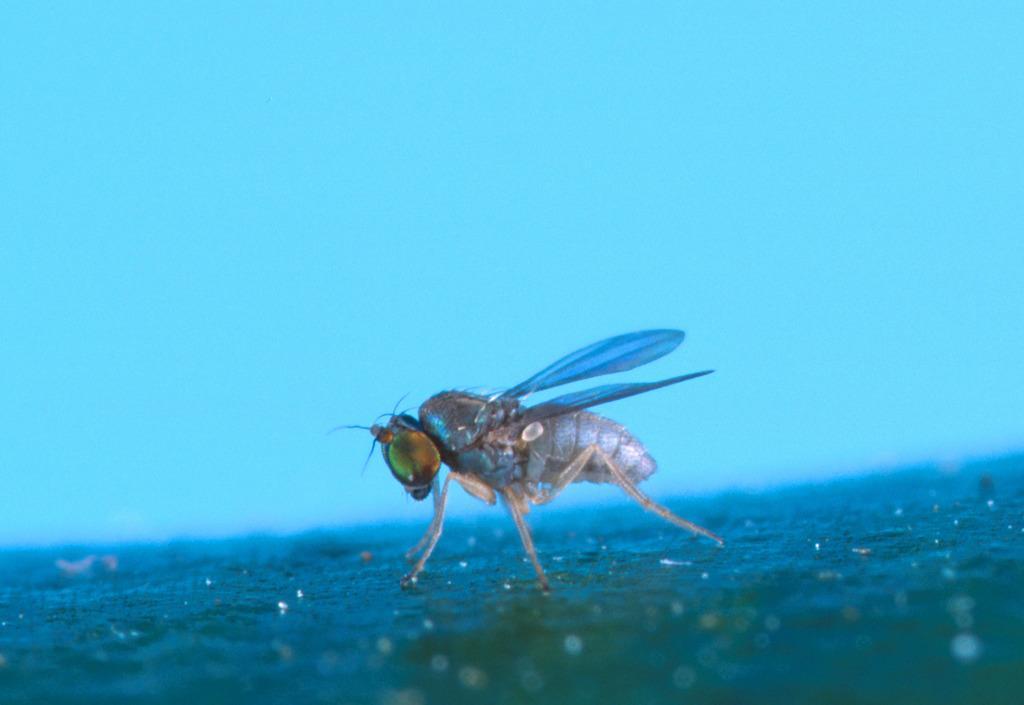Please provide a concise description of this image. In the picture we can see an insect standing on the surface with wings, legs, and eyes. 